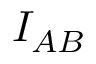Convert formula to latex. <formula><loc_0><loc_0><loc_500><loc_500>I _ { A B }</formula> 